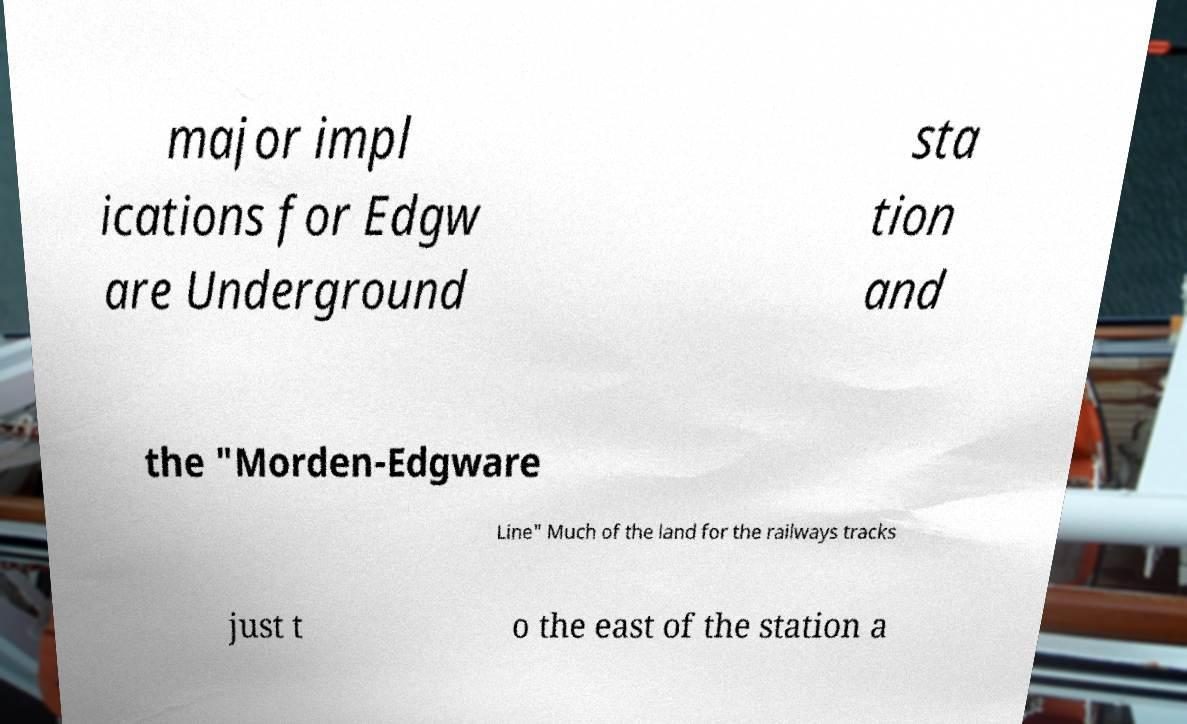Please read and relay the text visible in this image. What does it say? major impl ications for Edgw are Underground sta tion and the "Morden-Edgware Line" Much of the land for the railways tracks just t o the east of the station a 